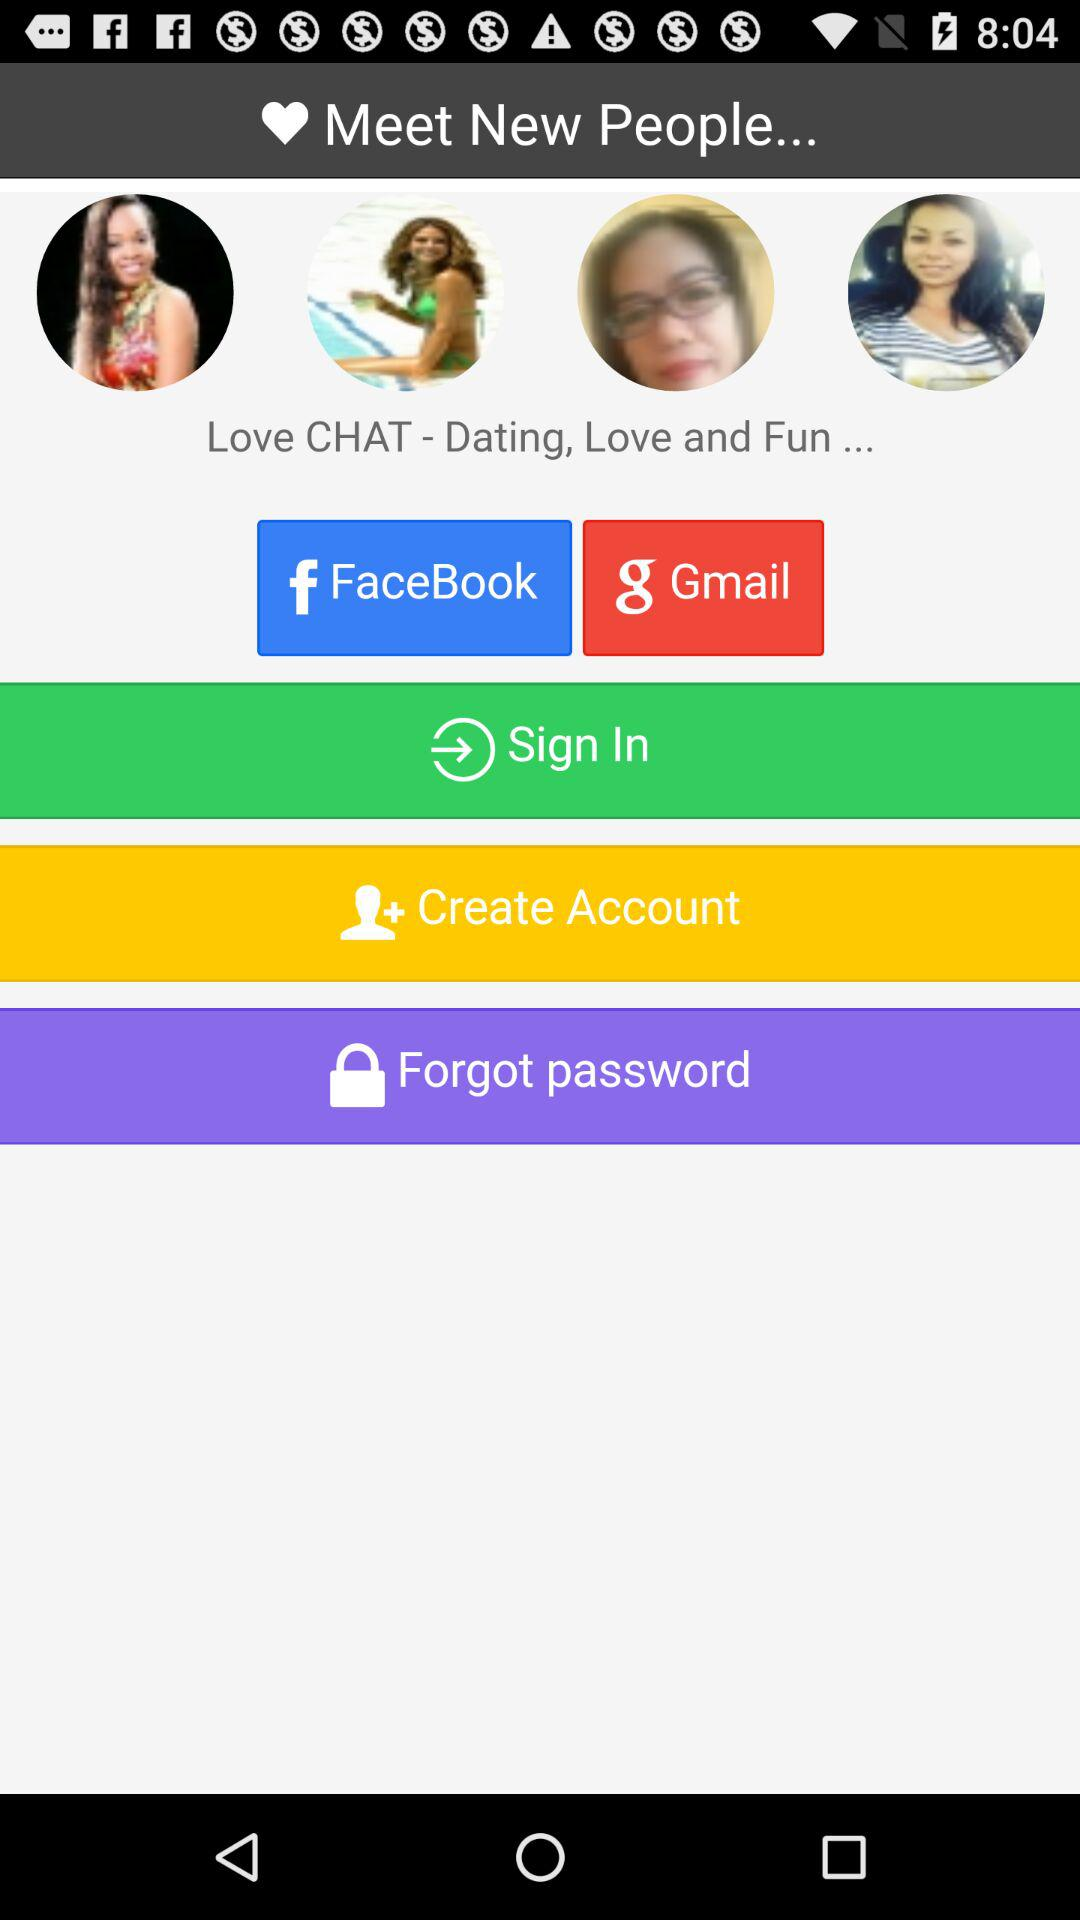What other applications can be used to log in to the profile? The other application that can be used to log in to the profile are "FaceBook" and "Gmail". 